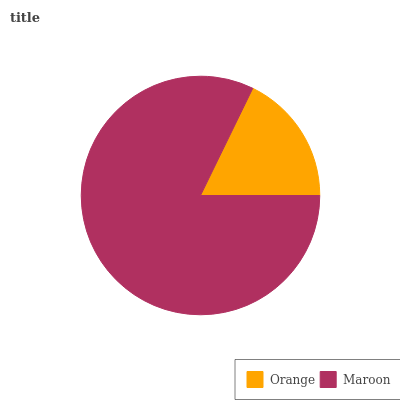Is Orange the minimum?
Answer yes or no. Yes. Is Maroon the maximum?
Answer yes or no. Yes. Is Maroon the minimum?
Answer yes or no. No. Is Maroon greater than Orange?
Answer yes or no. Yes. Is Orange less than Maroon?
Answer yes or no. Yes. Is Orange greater than Maroon?
Answer yes or no. No. Is Maroon less than Orange?
Answer yes or no. No. Is Maroon the high median?
Answer yes or no. Yes. Is Orange the low median?
Answer yes or no. Yes. Is Orange the high median?
Answer yes or no. No. Is Maroon the low median?
Answer yes or no. No. 